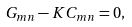Convert formula to latex. <formula><loc_0><loc_0><loc_500><loc_500>G _ { m n } - K C _ { m n } = 0 ,</formula> 